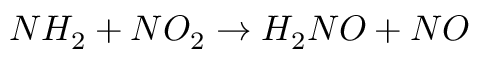<formula> <loc_0><loc_0><loc_500><loc_500>N H _ { 2 } + N O _ { 2 } \rightarrow H _ { 2 } N O + N O</formula> 